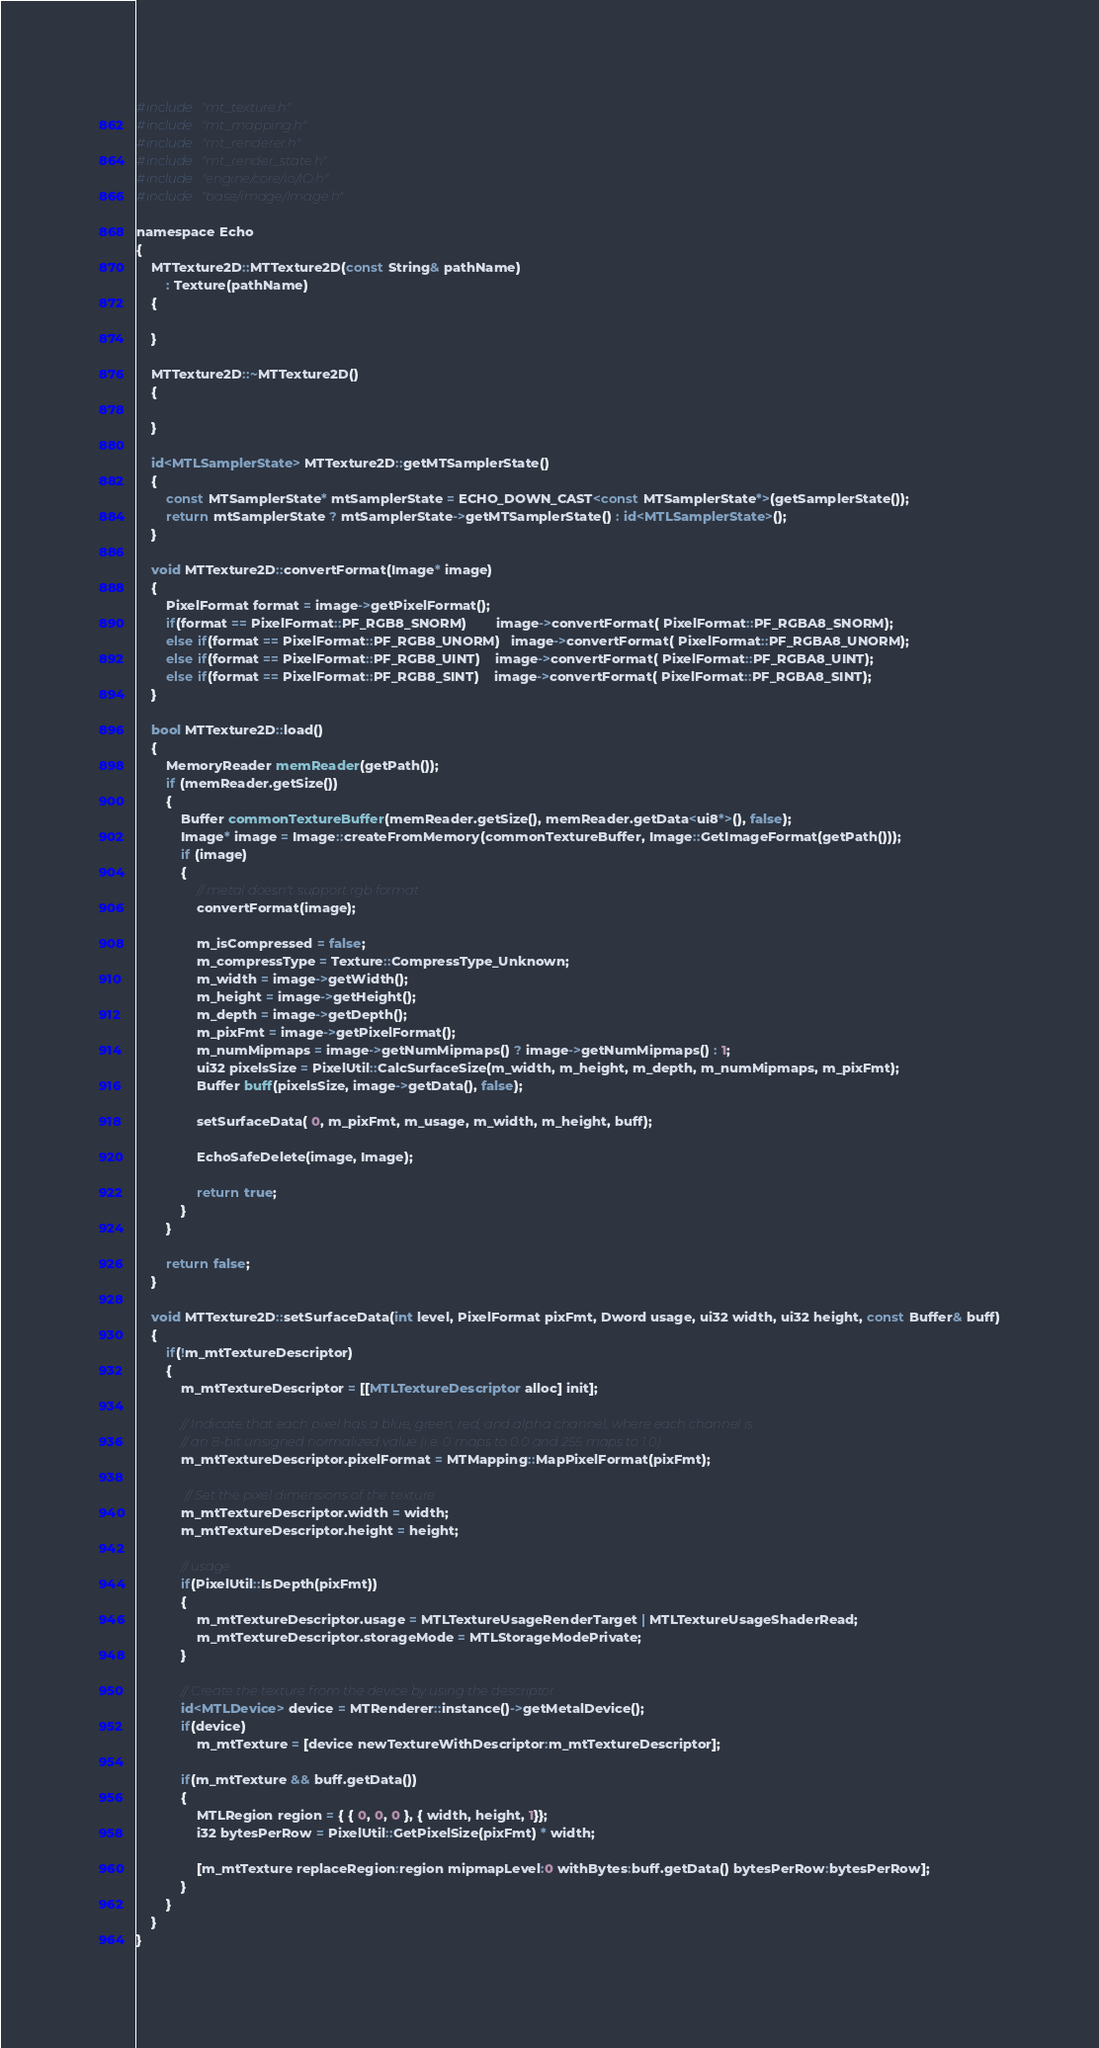<code> <loc_0><loc_0><loc_500><loc_500><_ObjectiveC_>#include "mt_texture.h"
#include "mt_mapping.h"
#include "mt_renderer.h"
#include "mt_render_state.h"
#include "engine/core/io/IO.h"
#include "base/image/Image.h"

namespace Echo
{
    MTTexture2D::MTTexture2D(const String& pathName)
        : Texture(pathName)
    {
        
    }

    MTTexture2D::~MTTexture2D()
    {
        
    }

    id<MTLSamplerState> MTTexture2D::getMTSamplerState()
    {
        const MTSamplerState* mtSamplerState = ECHO_DOWN_CAST<const MTSamplerState*>(getSamplerState());
        return mtSamplerState ? mtSamplerState->getMTSamplerState() : id<MTLSamplerState>();
    }

    void MTTexture2D::convertFormat(Image* image)
    {
        PixelFormat format = image->getPixelFormat();
        if(format == PixelFormat::PF_RGB8_SNORM)        image->convertFormat( PixelFormat::PF_RGBA8_SNORM);
        else if(format == PixelFormat::PF_RGB8_UNORM)   image->convertFormat( PixelFormat::PF_RGBA8_UNORM);
        else if(format == PixelFormat::PF_RGB8_UINT)    image->convertFormat( PixelFormat::PF_RGBA8_UINT);
        else if(format == PixelFormat::PF_RGB8_SINT)    image->convertFormat( PixelFormat::PF_RGBA8_SINT);
    }

    bool MTTexture2D::load()
    {
        MemoryReader memReader(getPath());
        if (memReader.getSize())
        {
            Buffer commonTextureBuffer(memReader.getSize(), memReader.getData<ui8*>(), false);
            Image* image = Image::createFromMemory(commonTextureBuffer, Image::GetImageFormat(getPath()));
            if (image)
            {
                // metal doesn't support rgb format
                convertFormat(image);
                
                m_isCompressed = false;
                m_compressType = Texture::CompressType_Unknown;
                m_width = image->getWidth();
                m_height = image->getHeight();
                m_depth = image->getDepth();
                m_pixFmt = image->getPixelFormat();
                m_numMipmaps = image->getNumMipmaps() ? image->getNumMipmaps() : 1;
                ui32 pixelsSize = PixelUtil::CalcSurfaceSize(m_width, m_height, m_depth, m_numMipmaps, m_pixFmt);
                Buffer buff(pixelsSize, image->getData(), false);

                setSurfaceData( 0, m_pixFmt, m_usage, m_width, m_height, buff);
                
                EchoSafeDelete(image, Image);

                return true;
            }
        }

        return false;
    }

    void MTTexture2D::setSurfaceData(int level, PixelFormat pixFmt, Dword usage, ui32 width, ui32 height, const Buffer& buff)
    {
        if(!m_mtTextureDescriptor)
        {
            m_mtTextureDescriptor = [[MTLTextureDescriptor alloc] init];
            
            // Indicate that each pixel has a blue, green, red, and alpha channel, where each channel is
            // an 8-bit unsigned normalized value (i.e. 0 maps to 0.0 and 255 maps to 1.0)
            m_mtTextureDescriptor.pixelFormat = MTMapping::MapPixelFormat(pixFmt);

             // Set the pixel dimensions of the texture
            m_mtTextureDescriptor.width = width;
            m_mtTextureDescriptor.height = height;
            
            // usage
            if(PixelUtil::IsDepth(pixFmt))
            {
                m_mtTextureDescriptor.usage = MTLTextureUsageRenderTarget | MTLTextureUsageShaderRead;
                m_mtTextureDescriptor.storageMode = MTLStorageModePrivate;
            }
            
            // Create the texture from the device by using the descriptor
            id<MTLDevice> device = MTRenderer::instance()->getMetalDevice();
            if(device)
                m_mtTexture = [device newTextureWithDescriptor:m_mtTextureDescriptor];
            
            if(m_mtTexture && buff.getData())
            {
                MTLRegion region = { { 0, 0, 0 }, { width, height, 1}};
                i32 bytesPerRow = PixelUtil::GetPixelSize(pixFmt) * width;
                
                [m_mtTexture replaceRegion:region mipmapLevel:0 withBytes:buff.getData() bytesPerRow:bytesPerRow];
            }
        }
    }
}
</code> 